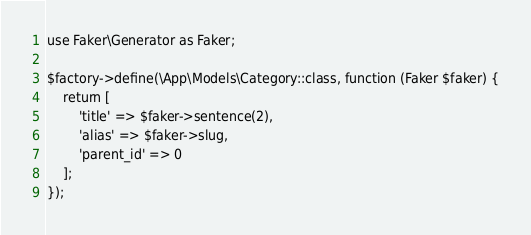Convert code to text. <code><loc_0><loc_0><loc_500><loc_500><_PHP_>use Faker\Generator as Faker;

$factory->define(\App\Models\Category::class, function (Faker $faker) {
    return [
        'title' => $faker->sentence(2),
        'alias' => $faker->slug,
        'parent_id' => 0
    ];
});
</code> 